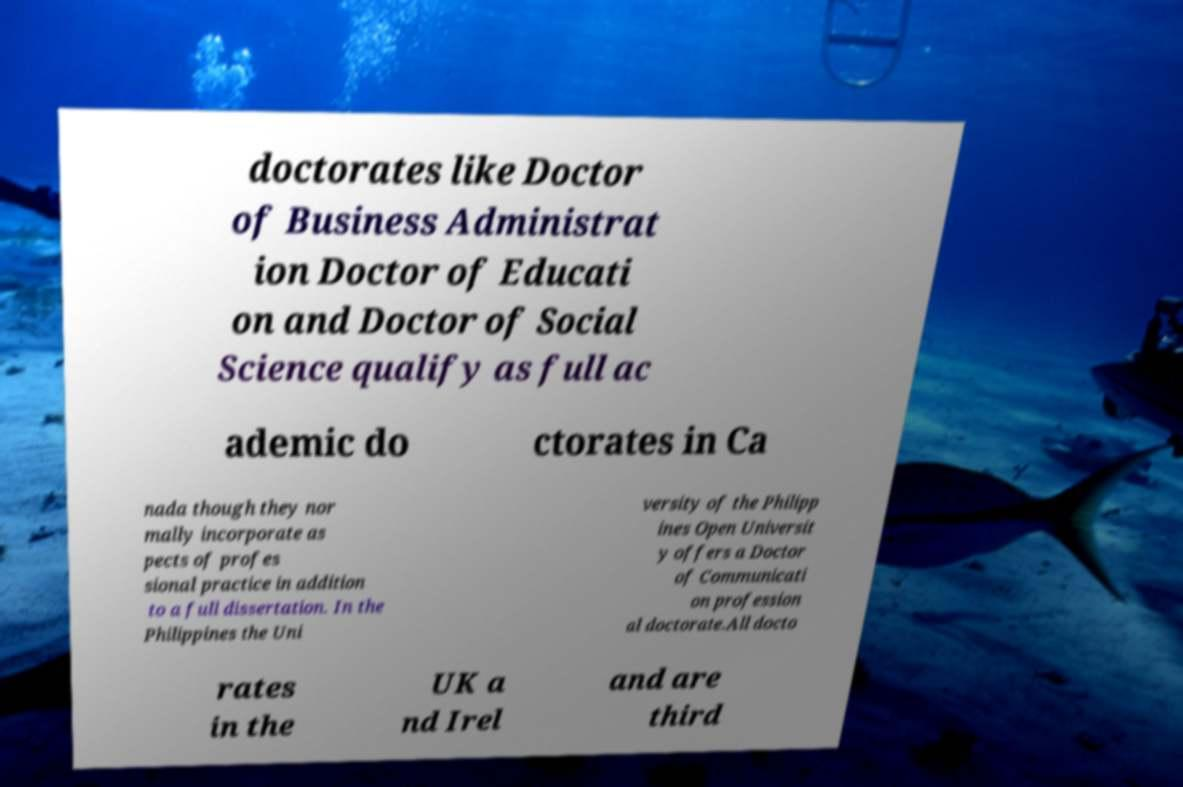Please identify and transcribe the text found in this image. doctorates like Doctor of Business Administrat ion Doctor of Educati on and Doctor of Social Science qualify as full ac ademic do ctorates in Ca nada though they nor mally incorporate as pects of profes sional practice in addition to a full dissertation. In the Philippines the Uni versity of the Philipp ines Open Universit y offers a Doctor of Communicati on profession al doctorate.All docto rates in the UK a nd Irel and are third 